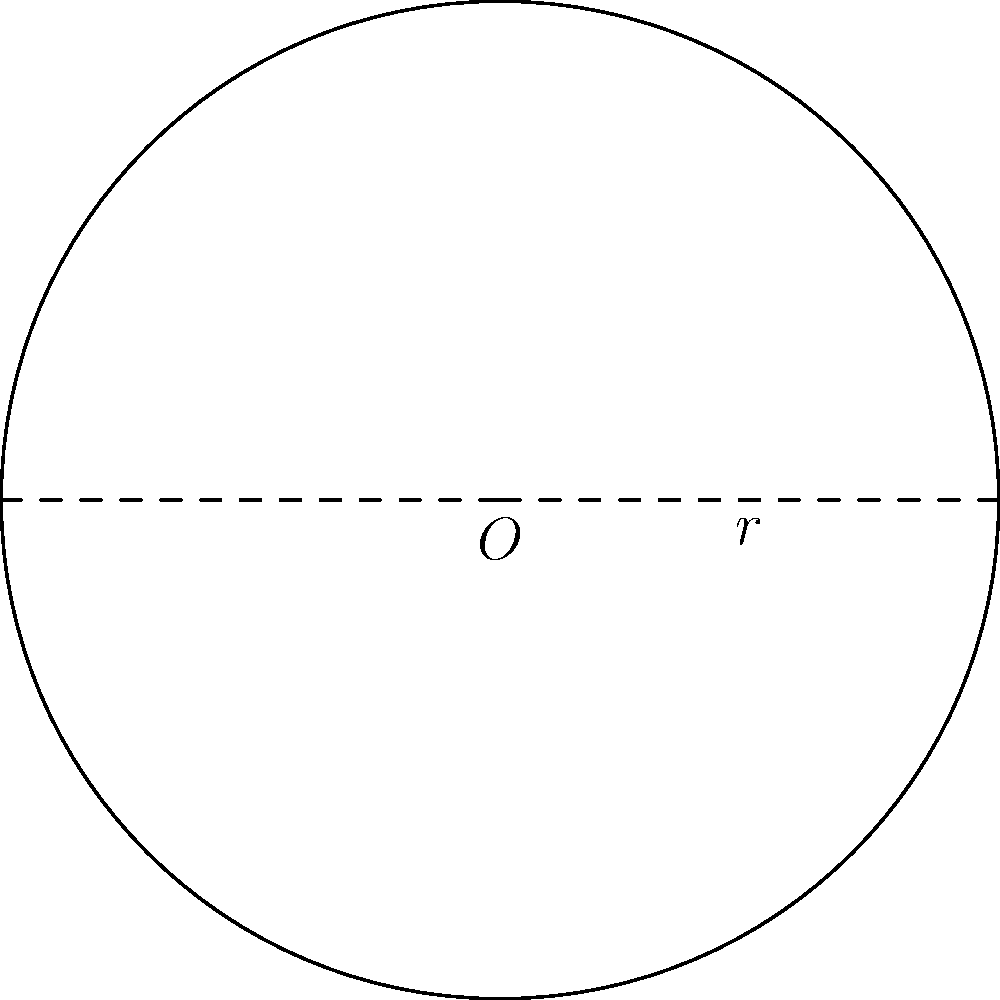As a conductor, you're planning a performance in a circular concert hall. The stage is perfectly circular with a radius of 15 meters. What is the area of the stage, rounded to the nearest whole number? To find the area of a circular stage, we need to use the formula for the area of a circle:

$$A = \pi r^2$$

Where:
$A$ is the area
$\pi$ (pi) is approximately 3.14159
$r$ is the radius of the circle

Given:
Radius ($r$) = 15 meters

Step 1: Substitute the radius into the formula
$$A = \pi (15)^2$$

Step 2: Calculate the square of the radius
$$A = \pi (225)$$

Step 3: Multiply by $\pi$
$$A = 3.14159 \times 225 \approx 706.86 \text{ square meters}$$

Step 4: Round to the nearest whole number
$$A \approx 707 \text{ square meters}$$

Therefore, the area of the circular stage is approximately 707 square meters.
Answer: 707 square meters 